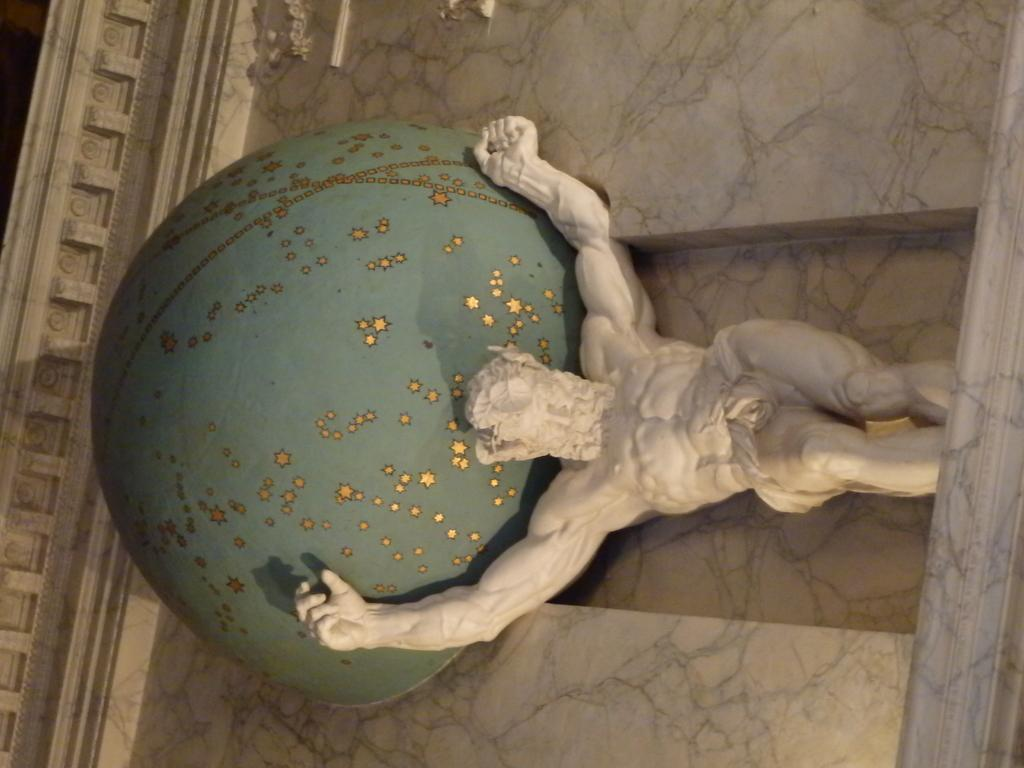What is the main subject in the image? There is a statue in the image. What else can be seen in the image besides the statue? There is a wall in the image. What type of root can be seen growing on the statue in the image? There is no root growing on the statue in the image. What is inside the jar that is placed on the statue in the image? There is no jar present on the statue in the image. 